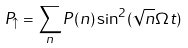<formula> <loc_0><loc_0><loc_500><loc_500>P _ { \uparrow } = \sum _ { n } P ( n ) \sin ^ { 2 } ( \sqrt { n } \Omega t )</formula> 